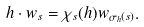<formula> <loc_0><loc_0><loc_500><loc_500>h \cdot w _ { s } = \chi _ { s } ( h ) w _ { \sigma _ { h } ( s ) } .</formula> 